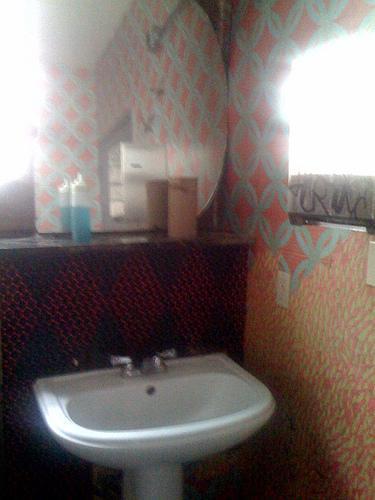How many mirrors are there?
Give a very brief answer. 2. How many people are washing hand in the bathroom?
Give a very brief answer. 0. 